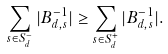Convert formula to latex. <formula><loc_0><loc_0><loc_500><loc_500>\sum _ { s \in S _ { d } ^ { - } } | B _ { d , s } ^ { - 1 } | \geq \sum _ { s \in S _ { d } ^ { + } } | B _ { d , s } ^ { - 1 } | .</formula> 